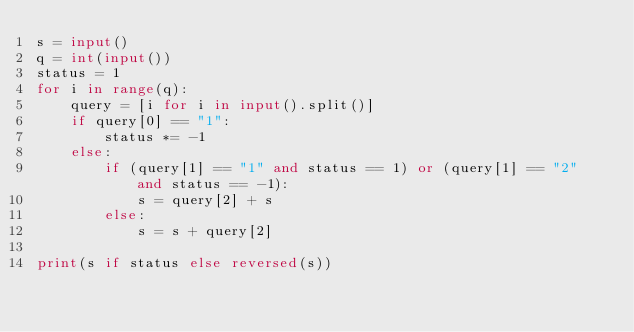Convert code to text. <code><loc_0><loc_0><loc_500><loc_500><_Python_>s = input()
q = int(input())
status = 1
for i in range(q):
    query = [i for i in input().split()]
    if query[0] == "1":
        status *= -1
    else:
        if (query[1] == "1" and status == 1) or (query[1] == "2" and status == -1):
            s = query[2] + s
        else:
            s = s + query[2]

print(s if status else reversed(s))</code> 